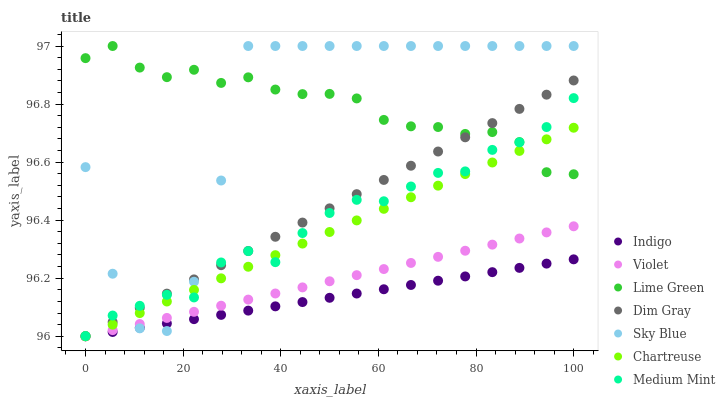Does Indigo have the minimum area under the curve?
Answer yes or no. Yes. Does Lime Green have the maximum area under the curve?
Answer yes or no. Yes. Does Dim Gray have the minimum area under the curve?
Answer yes or no. No. Does Dim Gray have the maximum area under the curve?
Answer yes or no. No. Is Indigo the smoothest?
Answer yes or no. Yes. Is Sky Blue the roughest?
Answer yes or no. Yes. Is Dim Gray the smoothest?
Answer yes or no. No. Is Dim Gray the roughest?
Answer yes or no. No. Does Dim Gray have the lowest value?
Answer yes or no. Yes. Does Sky Blue have the lowest value?
Answer yes or no. No. Does Lime Green have the highest value?
Answer yes or no. Yes. Does Dim Gray have the highest value?
Answer yes or no. No. Is Violet less than Lime Green?
Answer yes or no. Yes. Is Medium Mint greater than Indigo?
Answer yes or no. Yes. Does Sky Blue intersect Indigo?
Answer yes or no. Yes. Is Sky Blue less than Indigo?
Answer yes or no. No. Is Sky Blue greater than Indigo?
Answer yes or no. No. Does Violet intersect Lime Green?
Answer yes or no. No. 